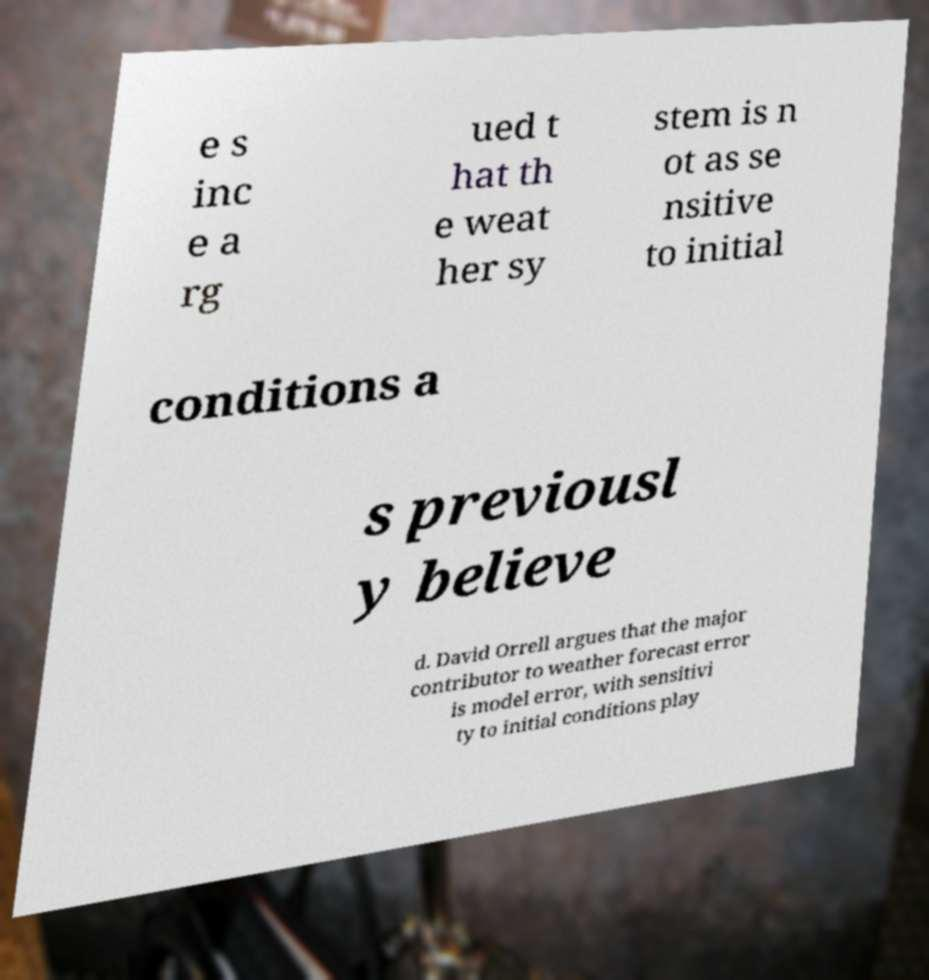Please read and relay the text visible in this image. What does it say? e s inc e a rg ued t hat th e weat her sy stem is n ot as se nsitive to initial conditions a s previousl y believe d. David Orrell argues that the major contributor to weather forecast error is model error, with sensitivi ty to initial conditions play 